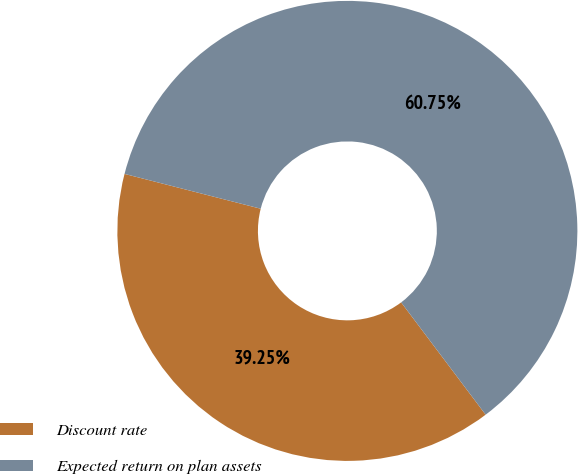Convert chart to OTSL. <chart><loc_0><loc_0><loc_500><loc_500><pie_chart><fcel>Discount rate<fcel>Expected return on plan assets<nl><fcel>39.25%<fcel>60.75%<nl></chart> 